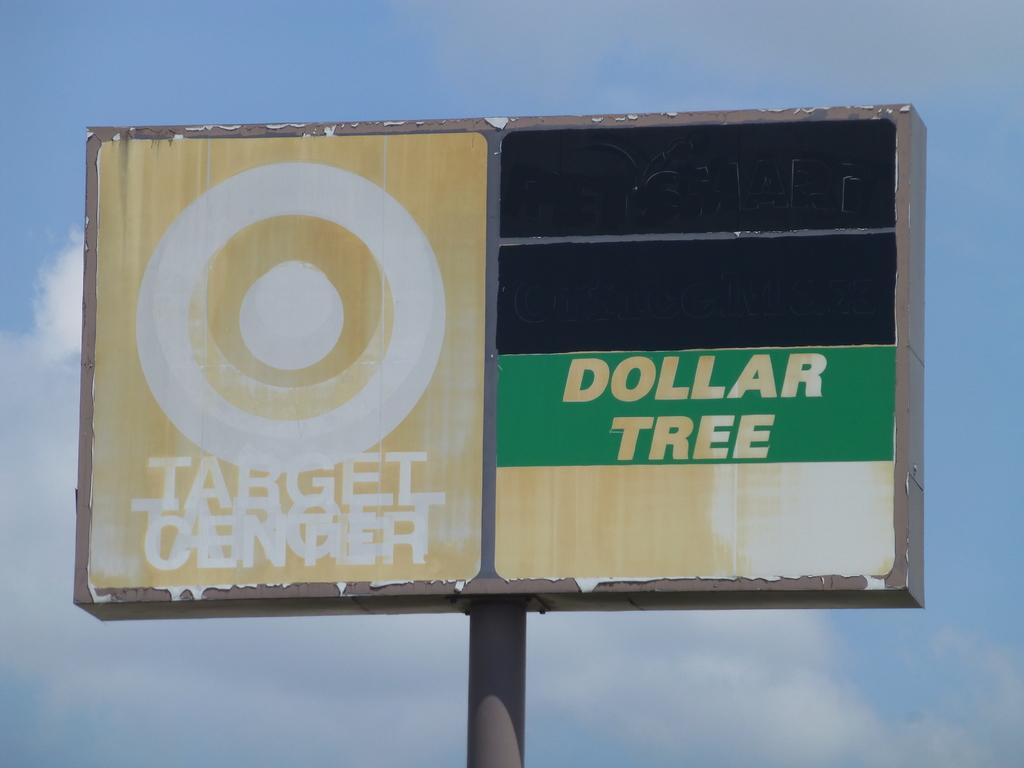What store is shown on the fading sign?
Keep it short and to the point. Target. 